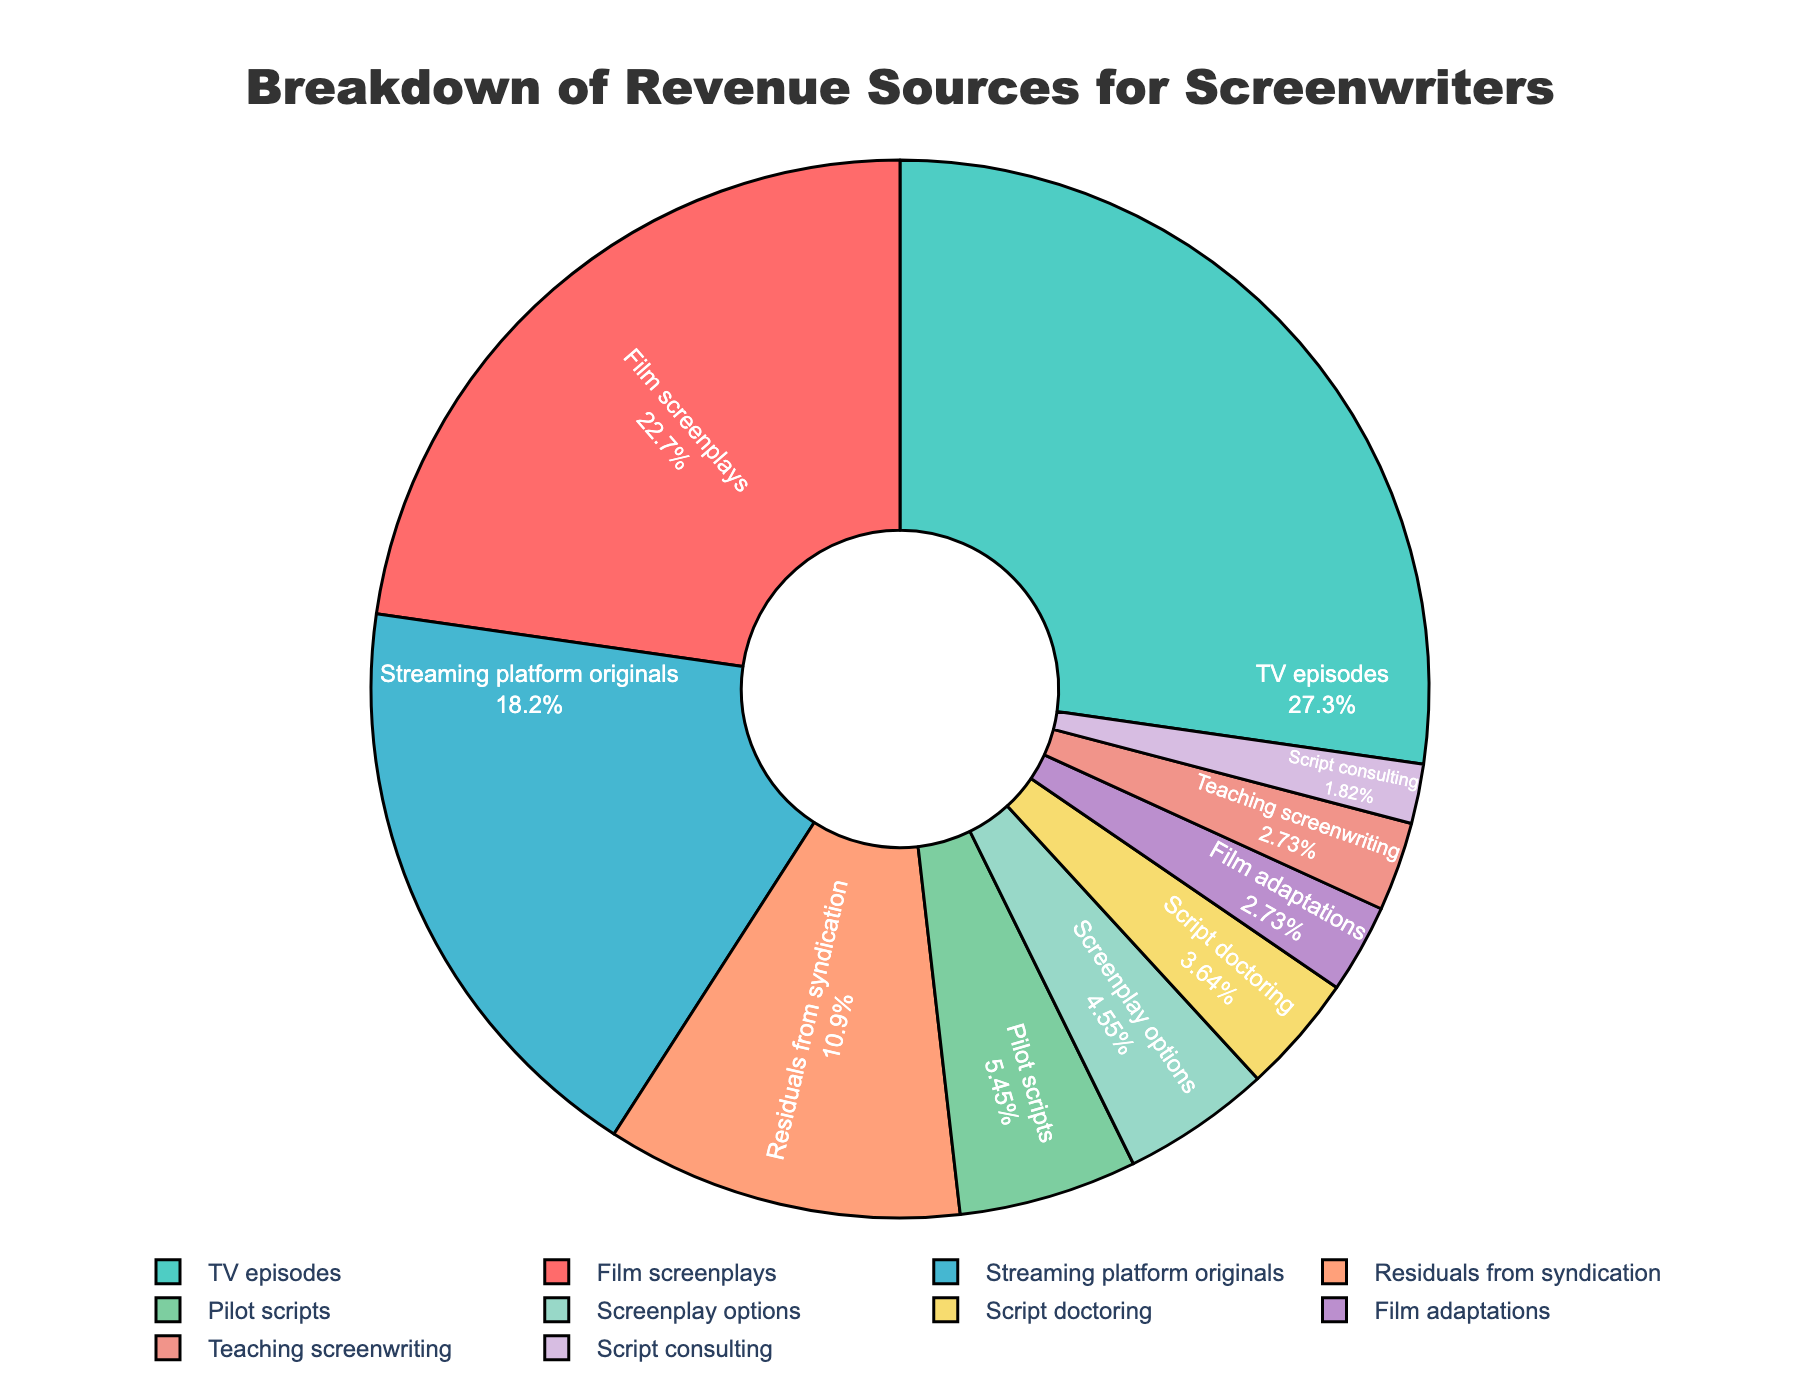What is the largest revenue source for screenwriters? To find the largest revenue source, examine the chart and identify the category with the biggest section. TV episodes have the largest section labeled "30%".
Answer: TV episodes How much more revenue do TV episodes generate compared to Film screenplays? Subtract the percentage of Film screenplays from that of TV episodes: 30% - 25% = 5%. This means TV episodes generate 5% more revenue than Film screenplays.
Answer: 5% What is the combined percentage of revenue from Pilot scripts and Script doctoring? Add the percentages of Pilot scripts and Script doctoring: 6% + 4% = 10%.
Answer: 10% Which sources contribute less than 5% to the total revenue? Identify the sections of the chart with less than 5%. These are Script consulting (2%), Film adaptations (3%), and Teaching screenwriting (3%).
Answer: Script consulting, Film adaptations, Teaching screenwriting What is the total revenue percentage generated by Screenplay options, Script doctoring, and Film adaptations combined? Add the percentages of Screenplay options, Script doctoring, and Film adaptations: 5% + 4% + 3% = 12%.
Answer: 12% Which category contributes double the revenue of Script doctoring? Identify the percentage of Script doctoring (4%) and find the category contributing 8%, which is not present. Thus, no category exactly doubles the revenue of Script doctoring.
Answer: None By how much does revenue from Residuals from syndication exceed that from Screenplay options? Subtract the percentage of Screenplay options from Residuals from syndication: 12% - 5% = 7%. Residuals from syndication exceed Screenplay options by 7%.
Answer: 7% Are the combined revenues of Film adaptations and Teaching screenwriting greater than Script doctoring? Add the percentages of Film adaptations (3%) and Teaching screenwriting (3%) and compare to Script doctoring (4%): 3% + 3% = 6%, which is greater than 4%.
Answer: Yes What percentage of the total revenue comes from categories under 10%? Identify and sum the percentages of categories under 10%: Streaming platform originals (20%) are under 10%. Thus, 5% + 4% + 3% + 6% + 3% + 2% = 23%.
Answer: 23% How does the revenue from Streaming platform originals compare to that from Script doctoring? Compare the percentages of Streaming platform originals (20%) and Script doctoring (4%). Streaming platform originals generate 16% more: 20% - 4% = 16%.
Answer: 16% 